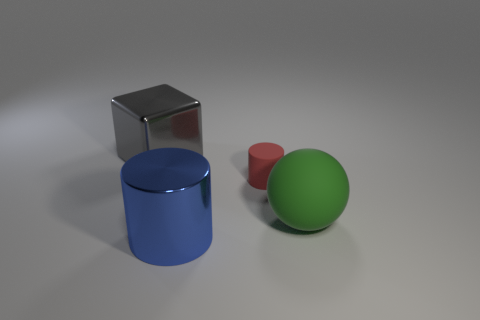If this image were part of an art exhibit, what title might you give it and why? A fitting title for this image could be 'Geometric Tranquility.' The combination of simple geometric shapes and the muted color palette evokes a sense of calm and order, inviting viewers to reflect on the interplay of form, color, and light in a serene setting. 